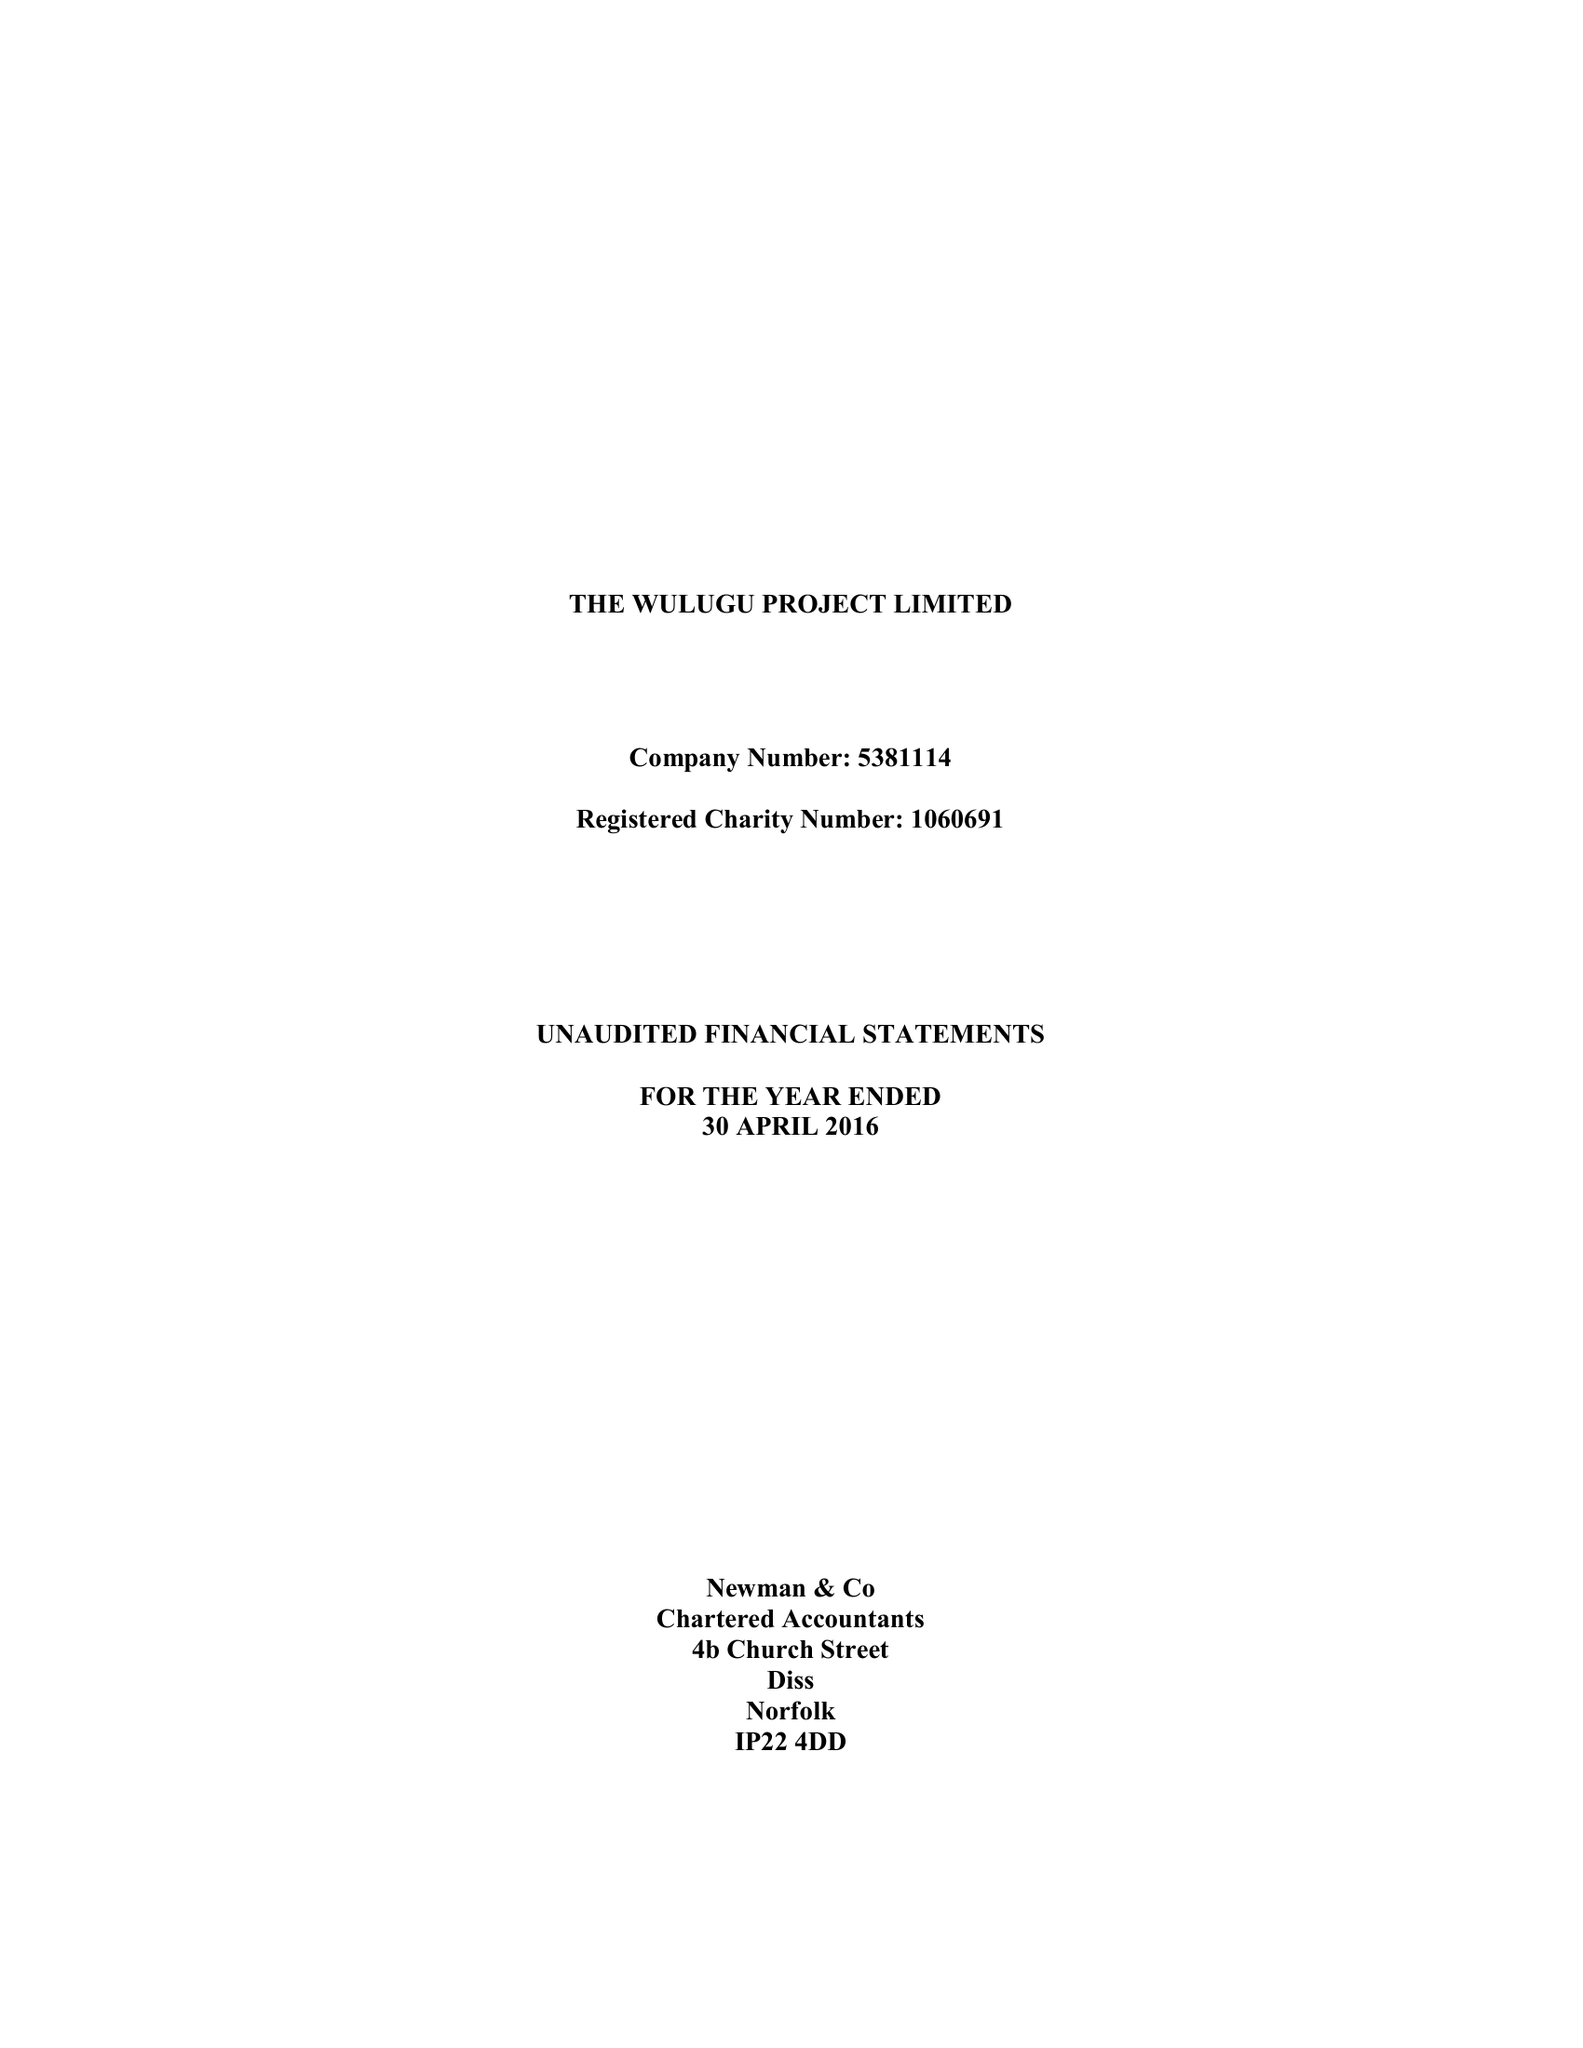What is the value for the charity_number?
Answer the question using a single word or phrase. 1060691 